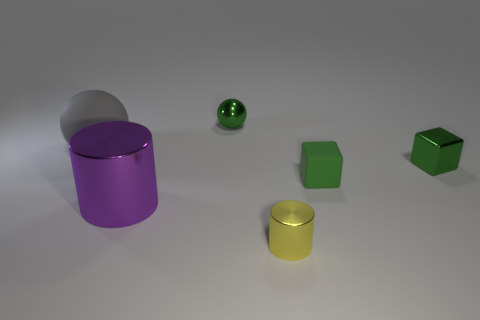Is the cylinder that is on the left side of the small yellow thing made of the same material as the yellow cylinder?
Your response must be concise. Yes. There is a large thing behind the small rubber object; what material is it?
Provide a short and direct response. Rubber. How big is the matte object that is behind the tiny cube that is behind the green rubber block?
Ensure brevity in your answer.  Large. Are there any other small objects made of the same material as the tiny yellow object?
Offer a terse response. Yes. There is a green shiny object that is behind the block that is right of the matte object that is in front of the gray sphere; what shape is it?
Your response must be concise. Sphere. Does the tiny metallic thing behind the metallic block have the same color as the shiny object that is to the right of the yellow shiny cylinder?
Ensure brevity in your answer.  Yes. There is a tiny yellow cylinder; are there any rubber things left of it?
Your response must be concise. Yes. How many other things are the same shape as the large matte object?
Your answer should be very brief. 1. There is a metal cylinder that is behind the metal cylinder in front of the metallic thing left of the tiny metal ball; what is its color?
Give a very brief answer. Purple. Are the cylinder that is to the left of the green ball and the large thing to the left of the purple metal cylinder made of the same material?
Make the answer very short. No. 